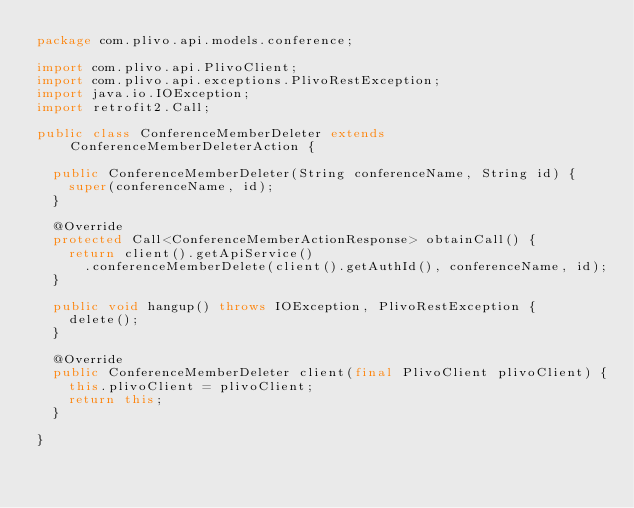<code> <loc_0><loc_0><loc_500><loc_500><_Java_>package com.plivo.api.models.conference;

import com.plivo.api.PlivoClient;
import com.plivo.api.exceptions.PlivoRestException;
import java.io.IOException;
import retrofit2.Call;

public class ConferenceMemberDeleter extends ConferenceMemberDeleterAction {

  public ConferenceMemberDeleter(String conferenceName, String id) {
    super(conferenceName, id);
  }

  @Override
  protected Call<ConferenceMemberActionResponse> obtainCall() {
    return client().getApiService()
      .conferenceMemberDelete(client().getAuthId(), conferenceName, id);
  }

  public void hangup() throws IOException, PlivoRestException {
    delete();
  }

  @Override
  public ConferenceMemberDeleter client(final PlivoClient plivoClient) {
    this.plivoClient = plivoClient;
    return this;
  }

}</code> 